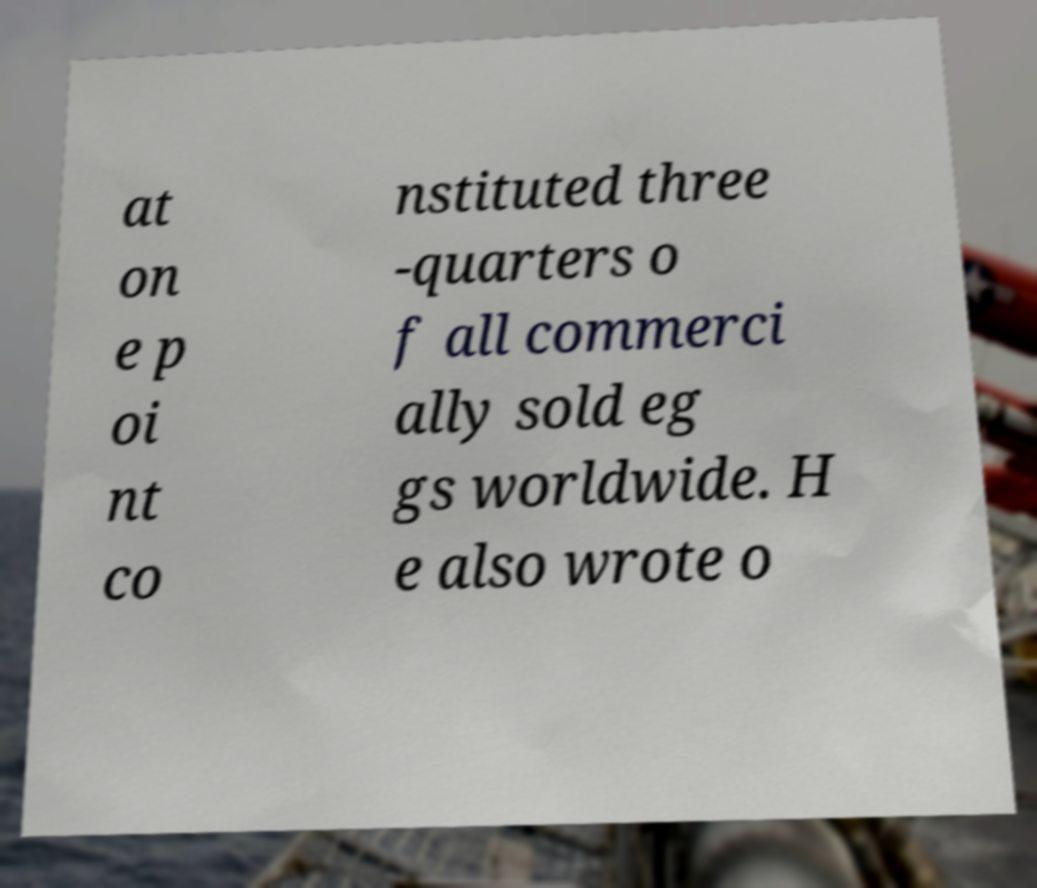There's text embedded in this image that I need extracted. Can you transcribe it verbatim? at on e p oi nt co nstituted three -quarters o f all commerci ally sold eg gs worldwide. H e also wrote o 